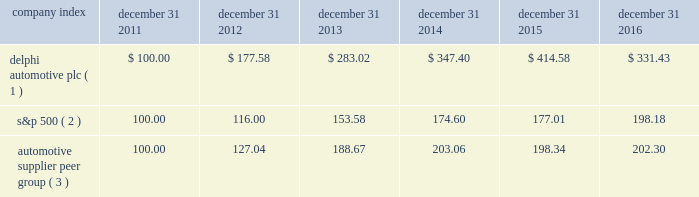Stock performance graph * $ 100 invested on december 31 , 2011 in our stock or in the relevant index , including reinvestment of dividends .
Fiscal year ended december 31 , 2016 .
( 1 ) delphi automotive plc ( 2 ) s&p 500 2013 standard & poor 2019s 500 total return index ( 3 ) automotive supplier peer group 2013 russell 3000 auto parts index , including american axle & manufacturing , borgwarner inc. , cooper tire & rubber company , dana inc. , delphi automotive plc , dorman products inc. , federal-mogul corp. , ford motor co. , general motors co. , gentex corp. , gentherm inc. , genuine parts co. , goodyear tire & rubber co. , johnson controls international plc , lear corp. , lkq corp. , meritor inc. , standard motor products inc. , stoneridge inc. , superior industries international , tenneco inc. , tesla motors inc. , tower international inc. , visteon corp. , and wabco holdings inc .
Company index december 31 , december 31 , december 31 , december 31 , december 31 , december 31 .
Dividends the company has declared and paid cash dividends of $ 0.25 and $ 0.29 per ordinary share in each quarter of 2015 and 2016 , respectively .
In addition , in january 2017 , the board of directors declared a regular quarterly cash dividend of $ 0.29 per ordinary share , payable on february 15 , 2017 to shareholders of record at the close of business on february 6 , 2017. .
What was the percentage increase in cash dividend from 2015 to 2016? 
Computations: ((0.29 - 0.25) / 0.25)
Answer: 0.16. 